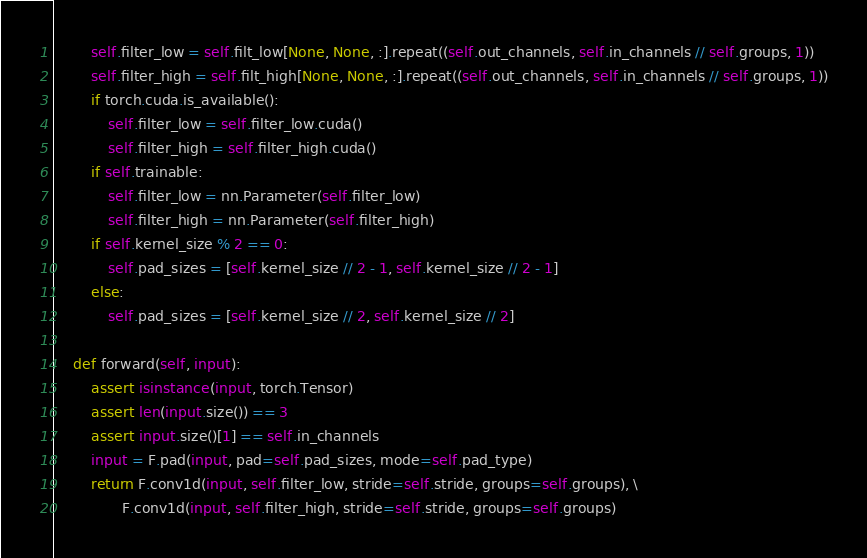Convert code to text. <code><loc_0><loc_0><loc_500><loc_500><_Python_>        self.filter_low = self.filt_low[None, None, :].repeat((self.out_channels, self.in_channels // self.groups, 1))
        self.filter_high = self.filt_high[None, None, :].repeat((self.out_channels, self.in_channels // self.groups, 1))
        if torch.cuda.is_available():
            self.filter_low = self.filter_low.cuda()
            self.filter_high = self.filter_high.cuda()
        if self.trainable:
            self.filter_low = nn.Parameter(self.filter_low)
            self.filter_high = nn.Parameter(self.filter_high)
        if self.kernel_size % 2 == 0:
            self.pad_sizes = [self.kernel_size // 2 - 1, self.kernel_size // 2 - 1]
        else:
            self.pad_sizes = [self.kernel_size // 2, self.kernel_size // 2]

    def forward(self, input):
        assert isinstance(input, torch.Tensor)
        assert len(input.size()) == 3
        assert input.size()[1] == self.in_channels
        input = F.pad(input, pad=self.pad_sizes, mode=self.pad_type)
        return F.conv1d(input, self.filter_low, stride=self.stride, groups=self.groups), \
               F.conv1d(input, self.filter_high, stride=self.stride, groups=self.groups)</code> 